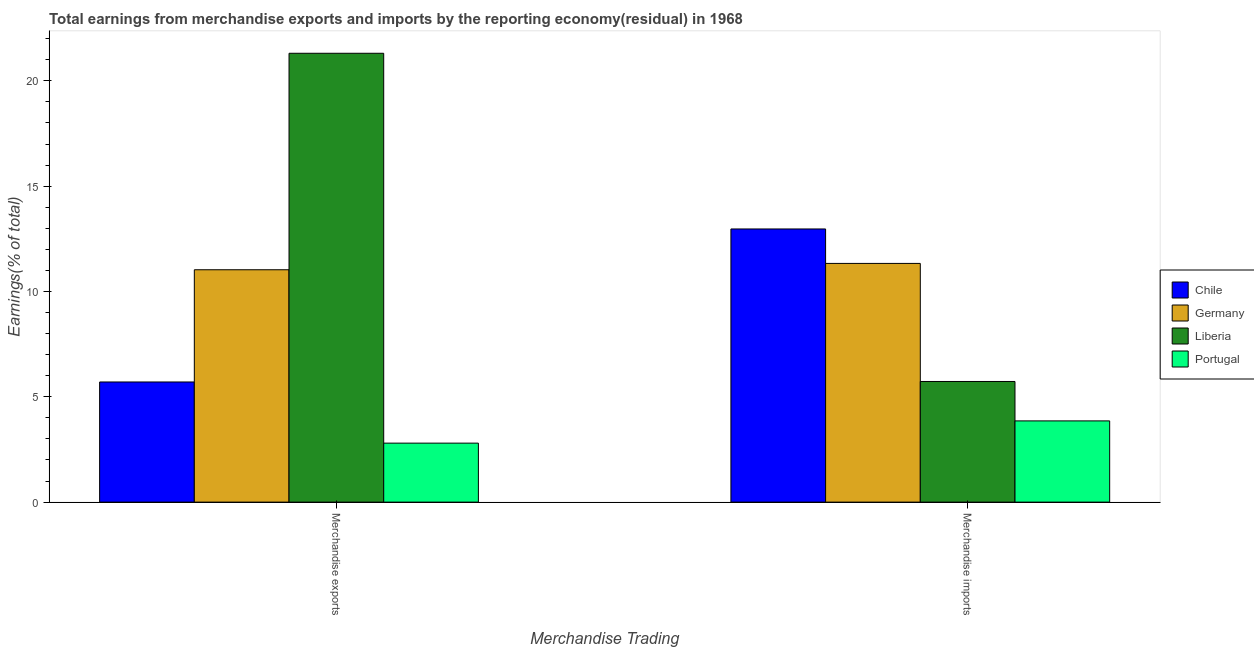Are the number of bars per tick equal to the number of legend labels?
Keep it short and to the point. Yes. Are the number of bars on each tick of the X-axis equal?
Keep it short and to the point. Yes. How many bars are there on the 2nd tick from the left?
Your answer should be very brief. 4. How many bars are there on the 2nd tick from the right?
Keep it short and to the point. 4. What is the label of the 2nd group of bars from the left?
Your answer should be very brief. Merchandise imports. What is the earnings from merchandise exports in Portugal?
Provide a short and direct response. 2.8. Across all countries, what is the maximum earnings from merchandise exports?
Offer a terse response. 21.31. Across all countries, what is the minimum earnings from merchandise exports?
Ensure brevity in your answer.  2.8. In which country was the earnings from merchandise exports maximum?
Provide a succinct answer. Liberia. In which country was the earnings from merchandise exports minimum?
Make the answer very short. Portugal. What is the total earnings from merchandise imports in the graph?
Make the answer very short. 33.88. What is the difference between the earnings from merchandise exports in Liberia and that in Chile?
Keep it short and to the point. 15.6. What is the difference between the earnings from merchandise exports in Liberia and the earnings from merchandise imports in Portugal?
Your answer should be very brief. 17.45. What is the average earnings from merchandise exports per country?
Offer a very short reply. 10.21. What is the difference between the earnings from merchandise exports and earnings from merchandise imports in Germany?
Make the answer very short. -0.3. In how many countries, is the earnings from merchandise imports greater than 11 %?
Offer a very short reply. 2. What is the ratio of the earnings from merchandise imports in Germany to that in Portugal?
Offer a terse response. 2.94. What does the 3rd bar from the left in Merchandise exports represents?
Your answer should be compact. Liberia. What does the 1st bar from the right in Merchandise exports represents?
Offer a terse response. Portugal. How many bars are there?
Provide a short and direct response. 8. Are all the bars in the graph horizontal?
Your answer should be very brief. No. How many countries are there in the graph?
Provide a succinct answer. 4. What is the difference between two consecutive major ticks on the Y-axis?
Your answer should be compact. 5. Are the values on the major ticks of Y-axis written in scientific E-notation?
Offer a terse response. No. Does the graph contain grids?
Your response must be concise. No. Where does the legend appear in the graph?
Your response must be concise. Center right. How are the legend labels stacked?
Ensure brevity in your answer.  Vertical. What is the title of the graph?
Your answer should be compact. Total earnings from merchandise exports and imports by the reporting economy(residual) in 1968. What is the label or title of the X-axis?
Your response must be concise. Merchandise Trading. What is the label or title of the Y-axis?
Your answer should be compact. Earnings(% of total). What is the Earnings(% of total) of Chile in Merchandise exports?
Your response must be concise. 5.7. What is the Earnings(% of total) in Germany in Merchandise exports?
Keep it short and to the point. 11.03. What is the Earnings(% of total) in Liberia in Merchandise exports?
Make the answer very short. 21.31. What is the Earnings(% of total) of Portugal in Merchandise exports?
Your answer should be very brief. 2.8. What is the Earnings(% of total) of Chile in Merchandise imports?
Give a very brief answer. 12.97. What is the Earnings(% of total) in Germany in Merchandise imports?
Keep it short and to the point. 11.33. What is the Earnings(% of total) of Liberia in Merchandise imports?
Your answer should be very brief. 5.73. What is the Earnings(% of total) of Portugal in Merchandise imports?
Your answer should be very brief. 3.86. Across all Merchandise Trading, what is the maximum Earnings(% of total) in Chile?
Your answer should be compact. 12.97. Across all Merchandise Trading, what is the maximum Earnings(% of total) in Germany?
Offer a terse response. 11.33. Across all Merchandise Trading, what is the maximum Earnings(% of total) of Liberia?
Offer a very short reply. 21.31. Across all Merchandise Trading, what is the maximum Earnings(% of total) in Portugal?
Offer a very short reply. 3.86. Across all Merchandise Trading, what is the minimum Earnings(% of total) in Chile?
Keep it short and to the point. 5.7. Across all Merchandise Trading, what is the minimum Earnings(% of total) in Germany?
Keep it short and to the point. 11.03. Across all Merchandise Trading, what is the minimum Earnings(% of total) of Liberia?
Give a very brief answer. 5.73. Across all Merchandise Trading, what is the minimum Earnings(% of total) in Portugal?
Give a very brief answer. 2.8. What is the total Earnings(% of total) in Chile in the graph?
Keep it short and to the point. 18.67. What is the total Earnings(% of total) in Germany in the graph?
Your response must be concise. 22.36. What is the total Earnings(% of total) of Liberia in the graph?
Offer a very short reply. 27.03. What is the total Earnings(% of total) in Portugal in the graph?
Your answer should be compact. 6.66. What is the difference between the Earnings(% of total) in Chile in Merchandise exports and that in Merchandise imports?
Give a very brief answer. -7.26. What is the difference between the Earnings(% of total) in Germany in Merchandise exports and that in Merchandise imports?
Your answer should be compact. -0.3. What is the difference between the Earnings(% of total) of Liberia in Merchandise exports and that in Merchandise imports?
Provide a short and direct response. 15.58. What is the difference between the Earnings(% of total) of Portugal in Merchandise exports and that in Merchandise imports?
Provide a short and direct response. -1.06. What is the difference between the Earnings(% of total) in Chile in Merchandise exports and the Earnings(% of total) in Germany in Merchandise imports?
Give a very brief answer. -5.63. What is the difference between the Earnings(% of total) in Chile in Merchandise exports and the Earnings(% of total) in Liberia in Merchandise imports?
Your answer should be very brief. -0.02. What is the difference between the Earnings(% of total) in Chile in Merchandise exports and the Earnings(% of total) in Portugal in Merchandise imports?
Offer a terse response. 1.85. What is the difference between the Earnings(% of total) in Germany in Merchandise exports and the Earnings(% of total) in Liberia in Merchandise imports?
Your answer should be very brief. 5.3. What is the difference between the Earnings(% of total) of Germany in Merchandise exports and the Earnings(% of total) of Portugal in Merchandise imports?
Give a very brief answer. 7.17. What is the difference between the Earnings(% of total) of Liberia in Merchandise exports and the Earnings(% of total) of Portugal in Merchandise imports?
Offer a terse response. 17.45. What is the average Earnings(% of total) in Chile per Merchandise Trading?
Your answer should be compact. 9.34. What is the average Earnings(% of total) in Germany per Merchandise Trading?
Give a very brief answer. 11.18. What is the average Earnings(% of total) in Liberia per Merchandise Trading?
Your response must be concise. 13.52. What is the average Earnings(% of total) of Portugal per Merchandise Trading?
Give a very brief answer. 3.33. What is the difference between the Earnings(% of total) in Chile and Earnings(% of total) in Germany in Merchandise exports?
Provide a short and direct response. -5.33. What is the difference between the Earnings(% of total) in Chile and Earnings(% of total) in Liberia in Merchandise exports?
Make the answer very short. -15.6. What is the difference between the Earnings(% of total) in Chile and Earnings(% of total) in Portugal in Merchandise exports?
Offer a terse response. 2.9. What is the difference between the Earnings(% of total) of Germany and Earnings(% of total) of Liberia in Merchandise exports?
Offer a very short reply. -10.28. What is the difference between the Earnings(% of total) in Germany and Earnings(% of total) in Portugal in Merchandise exports?
Provide a short and direct response. 8.23. What is the difference between the Earnings(% of total) in Liberia and Earnings(% of total) in Portugal in Merchandise exports?
Your answer should be very brief. 18.51. What is the difference between the Earnings(% of total) in Chile and Earnings(% of total) in Germany in Merchandise imports?
Offer a very short reply. 1.64. What is the difference between the Earnings(% of total) of Chile and Earnings(% of total) of Liberia in Merchandise imports?
Offer a terse response. 7.24. What is the difference between the Earnings(% of total) of Chile and Earnings(% of total) of Portugal in Merchandise imports?
Provide a short and direct response. 9.11. What is the difference between the Earnings(% of total) of Germany and Earnings(% of total) of Liberia in Merchandise imports?
Your answer should be compact. 5.6. What is the difference between the Earnings(% of total) in Germany and Earnings(% of total) in Portugal in Merchandise imports?
Offer a terse response. 7.48. What is the difference between the Earnings(% of total) in Liberia and Earnings(% of total) in Portugal in Merchandise imports?
Your response must be concise. 1.87. What is the ratio of the Earnings(% of total) of Chile in Merchandise exports to that in Merchandise imports?
Offer a terse response. 0.44. What is the ratio of the Earnings(% of total) of Germany in Merchandise exports to that in Merchandise imports?
Provide a short and direct response. 0.97. What is the ratio of the Earnings(% of total) of Liberia in Merchandise exports to that in Merchandise imports?
Provide a succinct answer. 3.72. What is the ratio of the Earnings(% of total) in Portugal in Merchandise exports to that in Merchandise imports?
Keep it short and to the point. 0.73. What is the difference between the highest and the second highest Earnings(% of total) in Chile?
Ensure brevity in your answer.  7.26. What is the difference between the highest and the second highest Earnings(% of total) of Germany?
Keep it short and to the point. 0.3. What is the difference between the highest and the second highest Earnings(% of total) in Liberia?
Keep it short and to the point. 15.58. What is the difference between the highest and the second highest Earnings(% of total) in Portugal?
Give a very brief answer. 1.06. What is the difference between the highest and the lowest Earnings(% of total) in Chile?
Offer a very short reply. 7.26. What is the difference between the highest and the lowest Earnings(% of total) in Germany?
Offer a terse response. 0.3. What is the difference between the highest and the lowest Earnings(% of total) in Liberia?
Your answer should be compact. 15.58. What is the difference between the highest and the lowest Earnings(% of total) of Portugal?
Give a very brief answer. 1.06. 